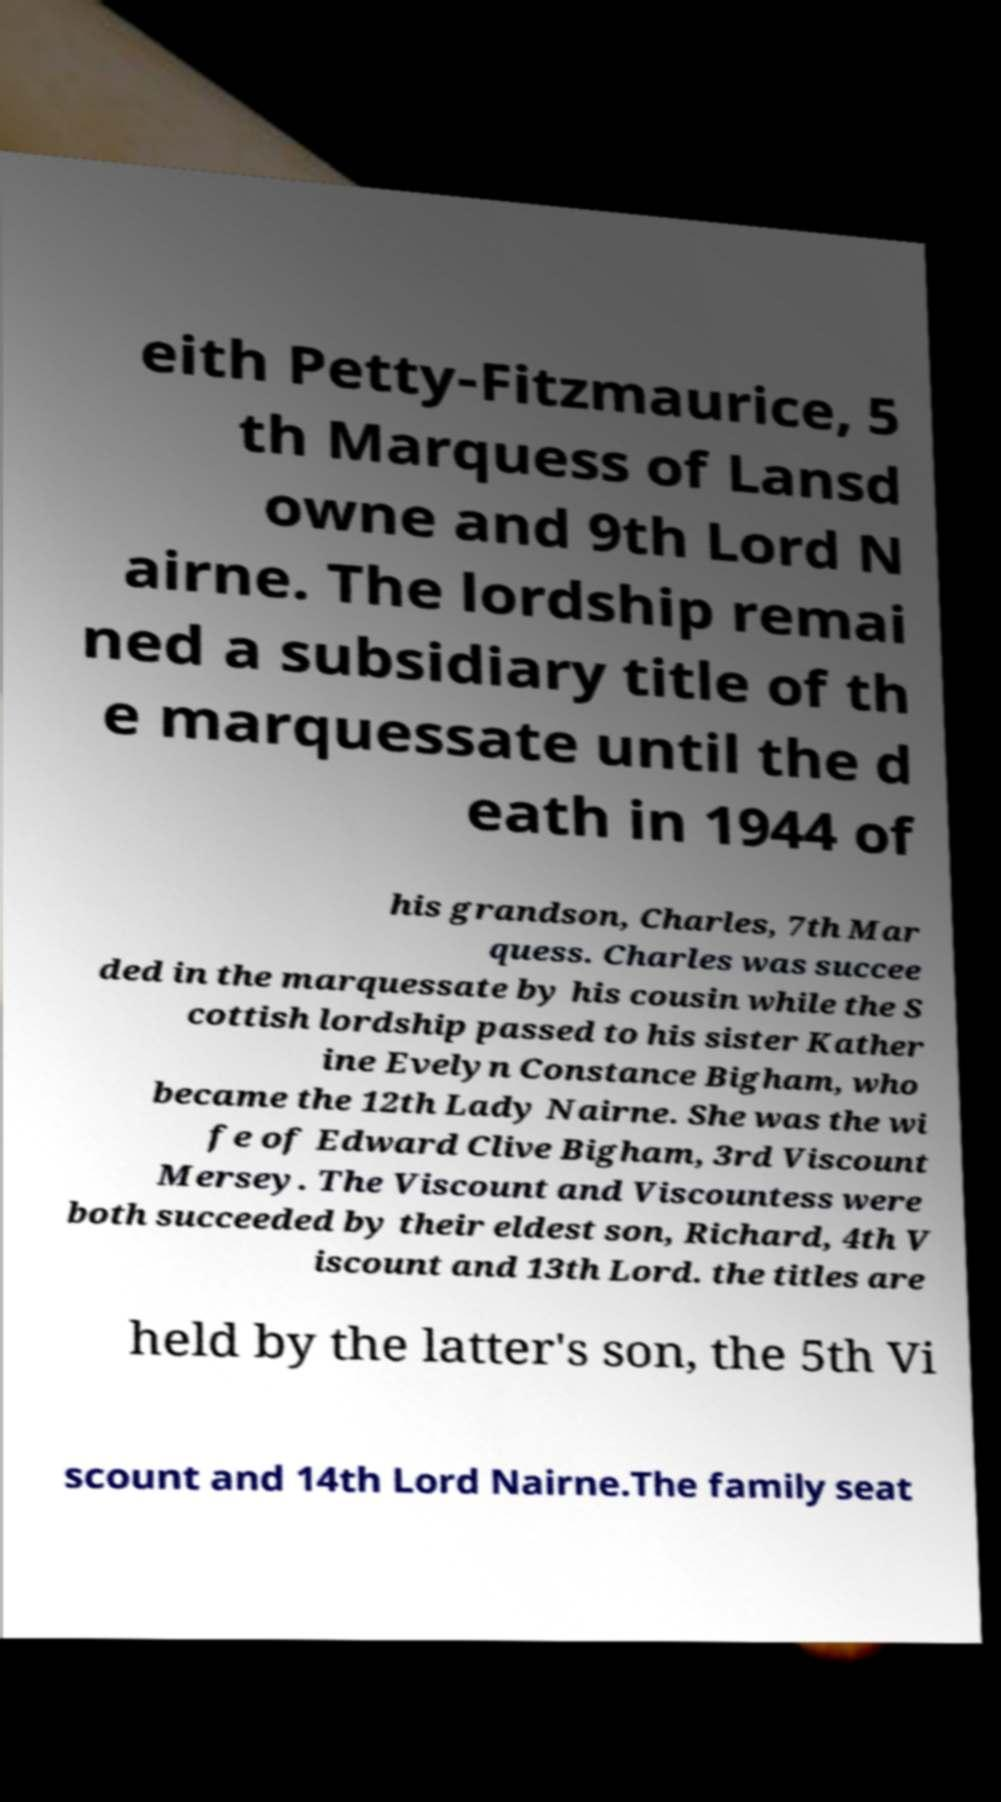There's text embedded in this image that I need extracted. Can you transcribe it verbatim? eith Petty-Fitzmaurice, 5 th Marquess of Lansd owne and 9th Lord N airne. The lordship remai ned a subsidiary title of th e marquessate until the d eath in 1944 of his grandson, Charles, 7th Mar quess. Charles was succee ded in the marquessate by his cousin while the S cottish lordship passed to his sister Kather ine Evelyn Constance Bigham, who became the 12th Lady Nairne. She was the wi fe of Edward Clive Bigham, 3rd Viscount Mersey. The Viscount and Viscountess were both succeeded by their eldest son, Richard, 4th V iscount and 13th Lord. the titles are held by the latter's son, the 5th Vi scount and 14th Lord Nairne.The family seat 